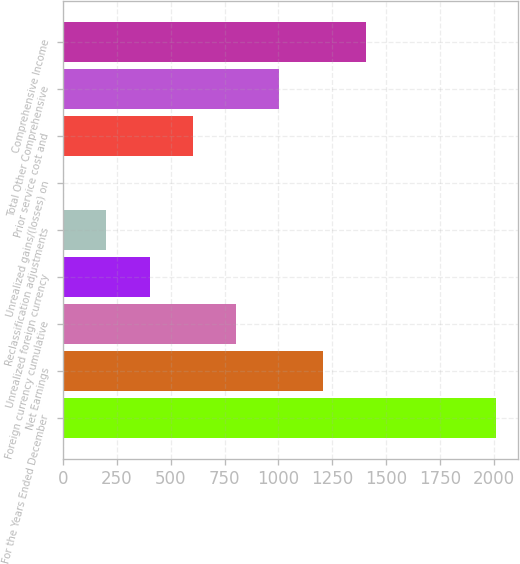Convert chart. <chart><loc_0><loc_0><loc_500><loc_500><bar_chart><fcel>For the Years Ended December<fcel>Net Earnings<fcel>Foreign currency cumulative<fcel>Unrealized foreign currency<fcel>Reclassification adjustments<fcel>Unrealized gains/(losses) on<fcel>Prior service cost and<fcel>Total Other Comprehensive<fcel>Comprehensive Income<nl><fcel>2009<fcel>1205.52<fcel>803.78<fcel>402.04<fcel>201.17<fcel>0.3<fcel>602.91<fcel>1004.65<fcel>1406.39<nl></chart> 